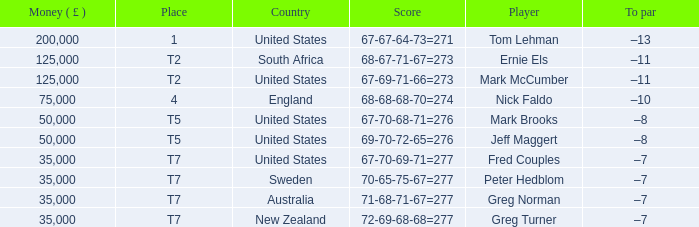What is To par, when Player is "Greg Turner"? –7. 